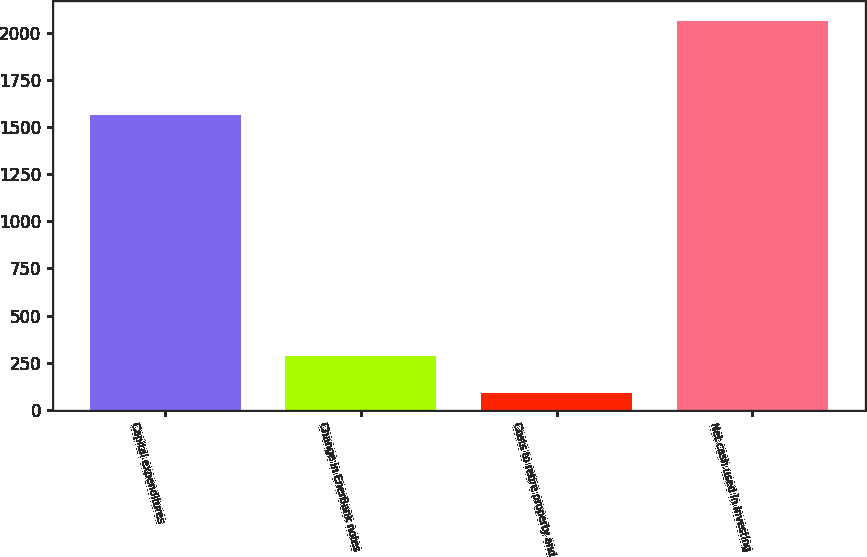Convert chart. <chart><loc_0><loc_0><loc_500><loc_500><bar_chart><fcel>Capital expenditures<fcel>Change in EnerBank notes<fcel>Costs to retire property and<fcel>Net cash used in investing<nl><fcel>1564<fcel>287.4<fcel>90<fcel>2064<nl></chart> 